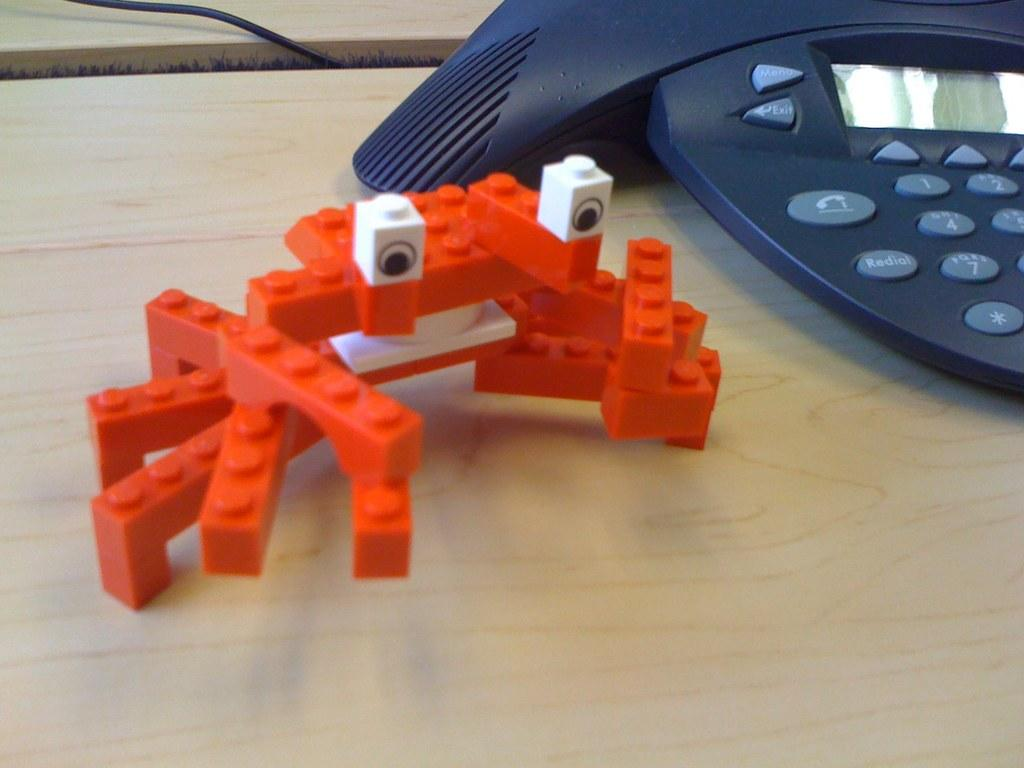<image>
Write a terse but informative summary of the picture. An orange crab shaped figure made of Legos next to a conference call phone with menu and exit buttons. 